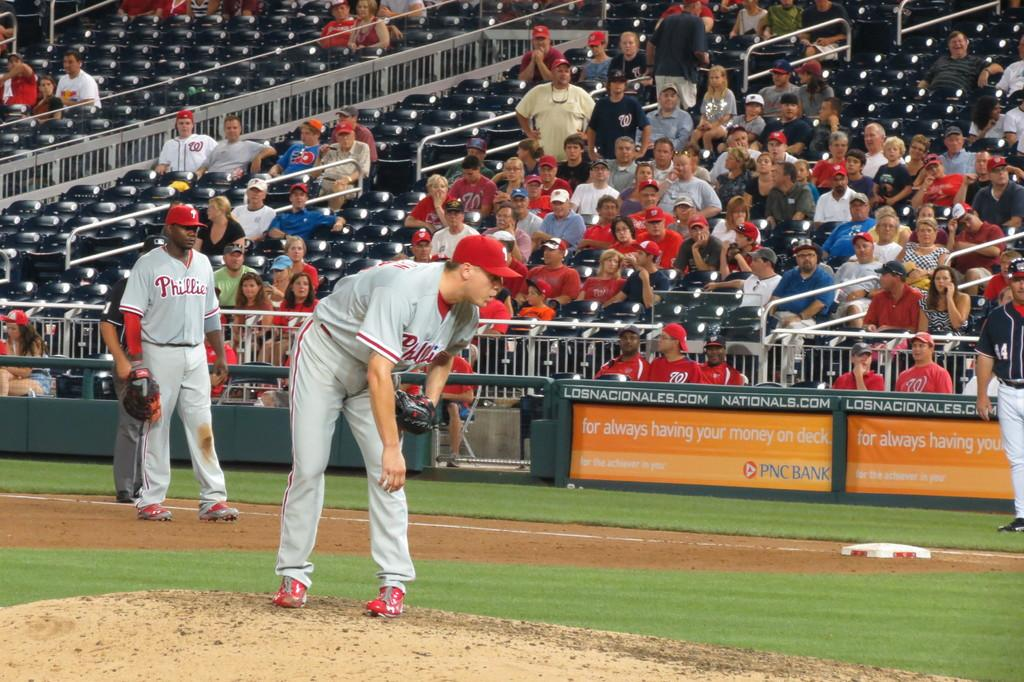<image>
Share a concise interpretation of the image provided. a couple of players that are on the Phillies getting ready to play 